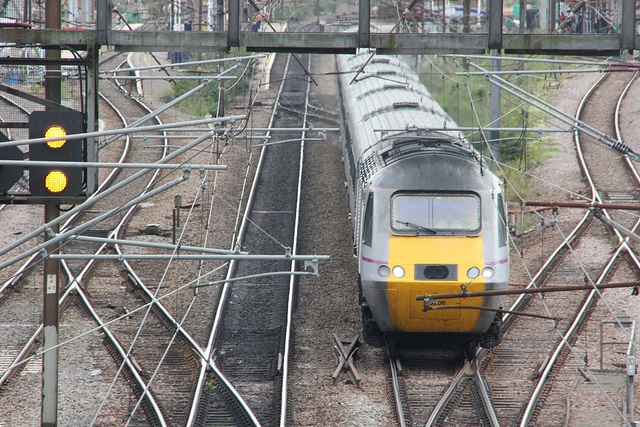Describe the objects in this image and their specific colors. I can see train in gray, lightgray, darkgray, and black tones and traffic light in gray, black, and purple tones in this image. 